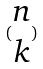Convert formula to latex. <formula><loc_0><loc_0><loc_500><loc_500>( \begin{matrix} n \\ k \end{matrix} )</formula> 